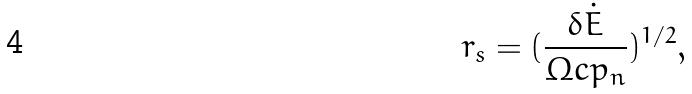Convert formula to latex. <formula><loc_0><loc_0><loc_500><loc_500>r _ { s } = ( \frac { \delta \dot { E } } { \Omega c p _ { n } } ) ^ { 1 / 2 } ,</formula> 